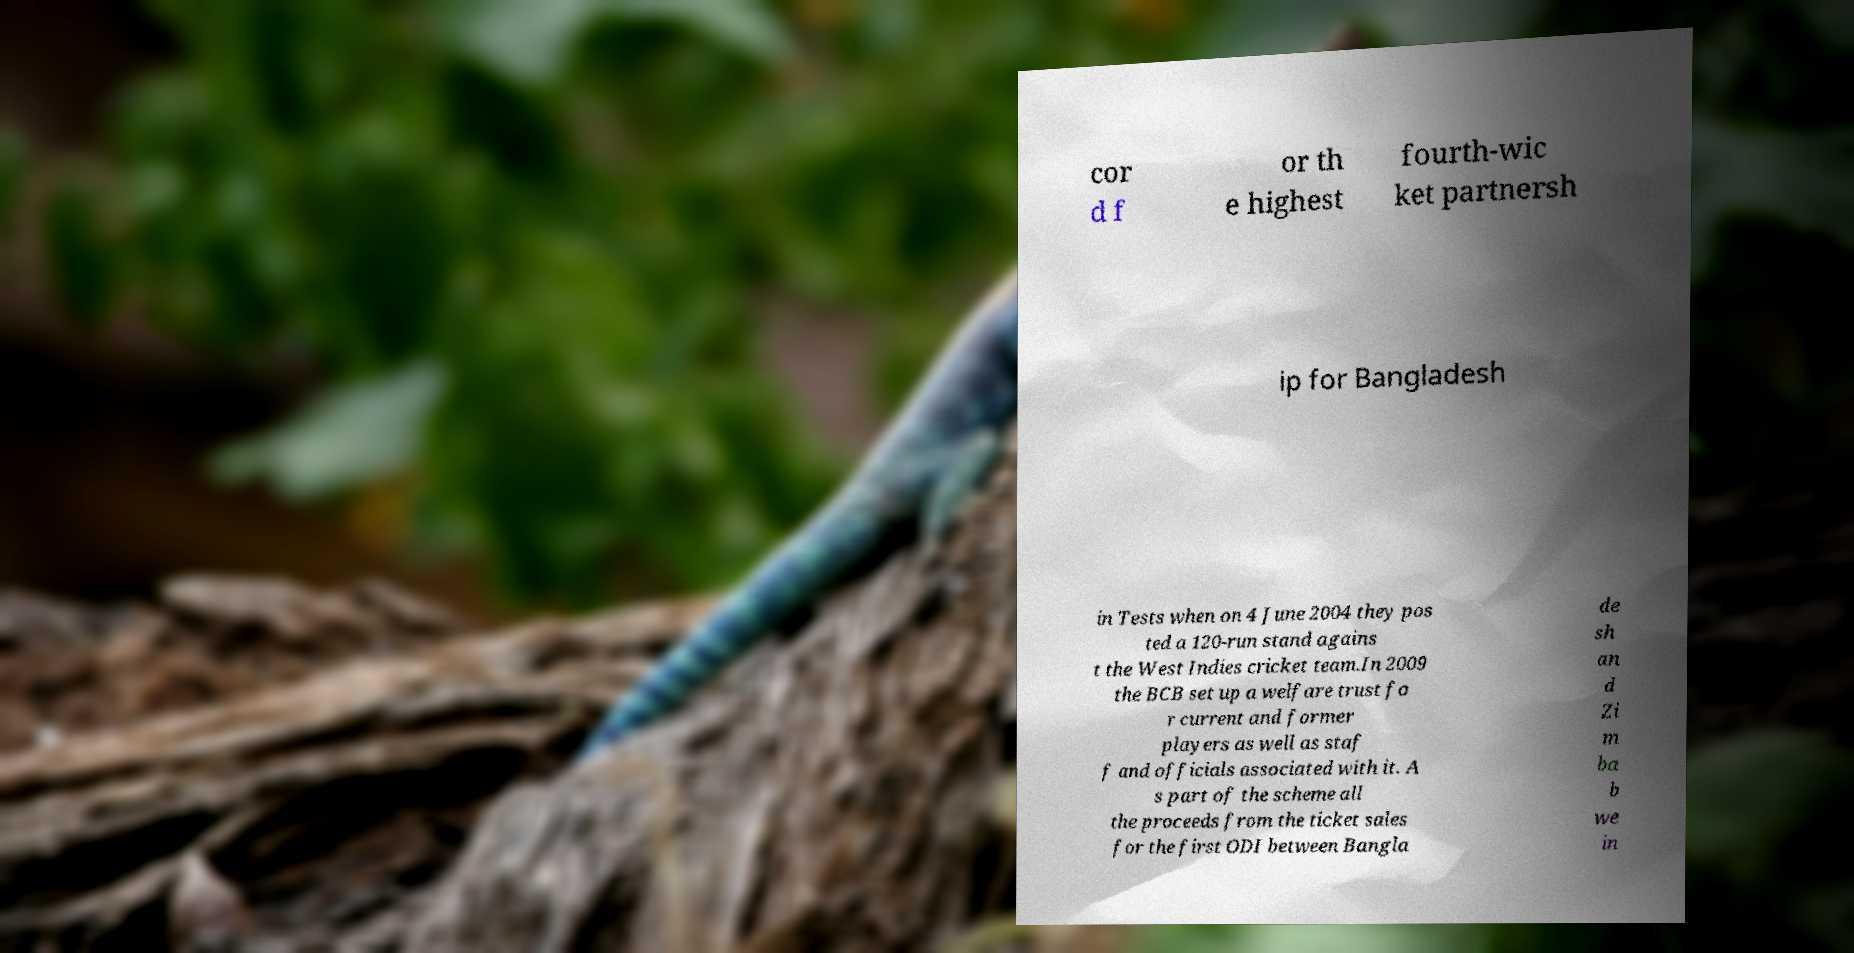Could you assist in decoding the text presented in this image and type it out clearly? cor d f or th e highest fourth-wic ket partnersh ip for Bangladesh in Tests when on 4 June 2004 they pos ted a 120-run stand agains t the West Indies cricket team.In 2009 the BCB set up a welfare trust fo r current and former players as well as staf f and officials associated with it. A s part of the scheme all the proceeds from the ticket sales for the first ODI between Bangla de sh an d Zi m ba b we in 